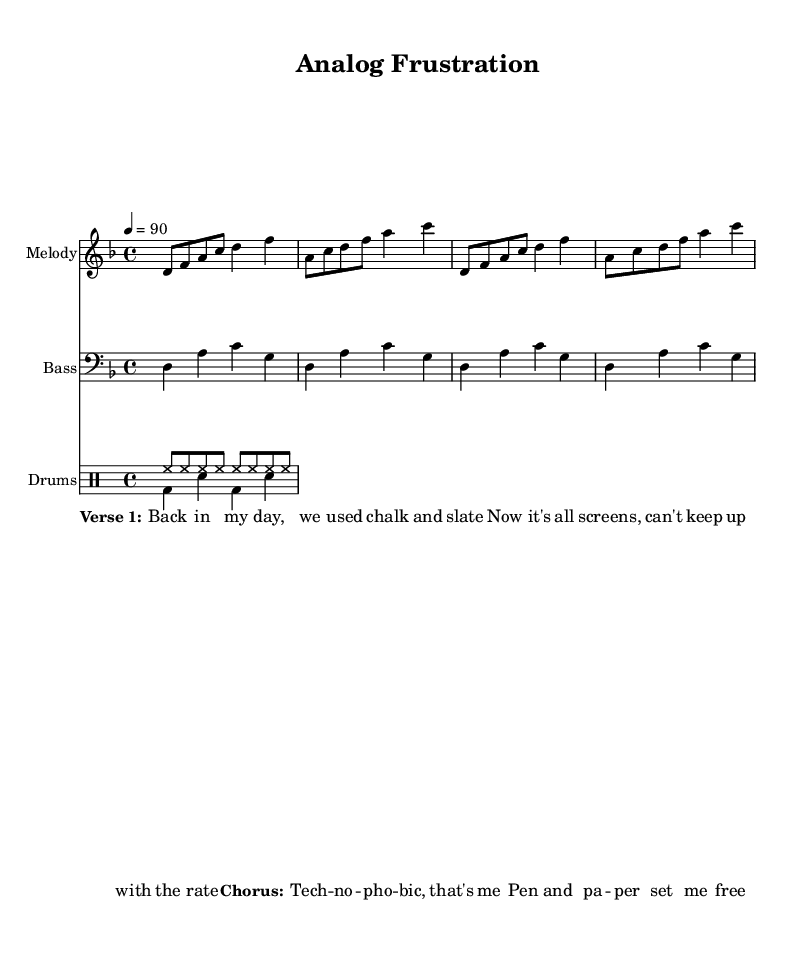What is the key signature of this music? The key signature is D minor, indicated by one flat (B flat) at the beginning of the staff.
Answer: D minor What is the time signature of the piece? The time signature is 4/4, shown at the beginning of the score which means there are four beats in a measure and the quarter note gets one beat.
Answer: 4/4 What is the tempo marking for this piece? The tempo marking is 90 beats per minute, indicated by the notation "4 = 90" which tells the performer the speed of the music.
Answer: 90 How many measures are there in the melody? The melody consists of four measures, as indicated by the grouping of notes and the presence of vertical bar lines separating each measure.
Answer: 4 What is the primary instrument for the bassline? The primary instrument for the bassline is the bass, as indicated by the label "Bass" under the corresponding staff.
Answer: Bass What lyrics are included in the chorus section? The lyrics in the chorus section are "Tech -- no -- pho -- bic, that's me Pen and pa -- per set me free," as depicted in the written text under the musical phrases.
Answer: Tech -- no -- pho -- bic, that's me Pen and pa -- per set me free What rhythmic pattern is represented by the "bd" and "sn" in the drum part? The "bd" represents the bass drum and "sn" represents the snare drum; these letters indicate specific parts of a standard drum kit with their corresponding rhythmic placement.
Answer: Bass drum and snare drum 